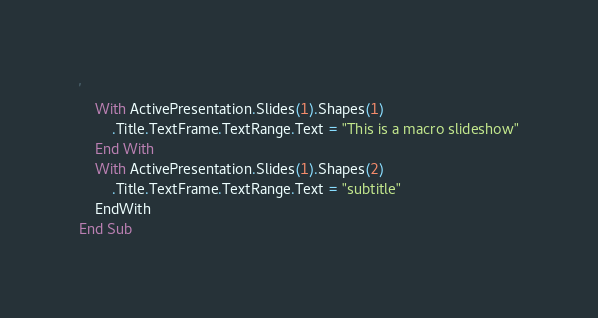Convert code to text. <code><loc_0><loc_0><loc_500><loc_500><_VisualBasic_>
'
    With ActivePresentation.Slides(1).Shapes(1)
        .Title.TextFrame.TextRange.Text = "This is a macro slideshow"
    End With
    With ActivePresentation.Slides(1).Shapes(2)
        .Title.TextFrame.TextRange.Text = "subtitle"
    EndWith
End Sub
</code> 